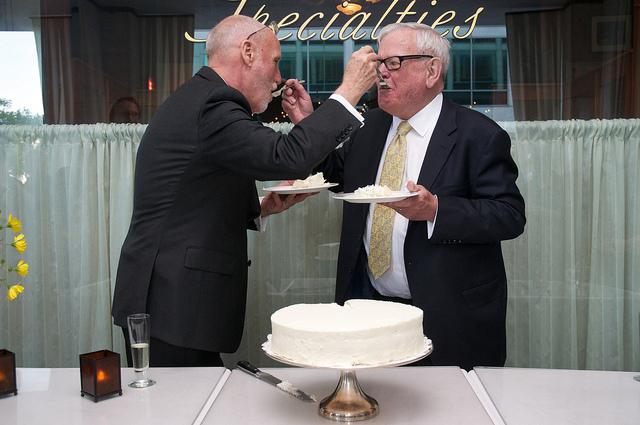How many slices of cake has been cut?
Write a very short answer. 2. What is sitting on the table in the foreground?
Write a very short answer. Cake. What is the man holding?
Give a very brief answer. Cake. Does this show a wedding?
Quick response, please. Yes. What color is the cake?
Write a very short answer. White. 